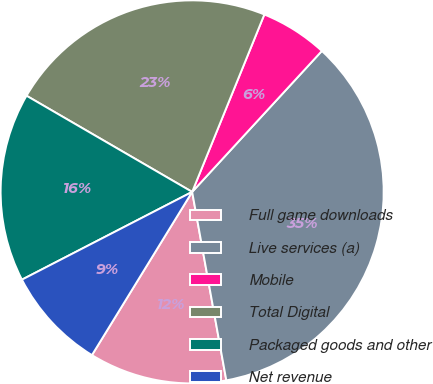Convert chart to OTSL. <chart><loc_0><loc_0><loc_500><loc_500><pie_chart><fcel>Full game downloads<fcel>Live services (a)<fcel>Mobile<fcel>Total Digital<fcel>Packaged goods and other<fcel>Net revenue<nl><fcel>11.62%<fcel>35.31%<fcel>5.69%<fcel>22.78%<fcel>15.95%<fcel>8.66%<nl></chart> 